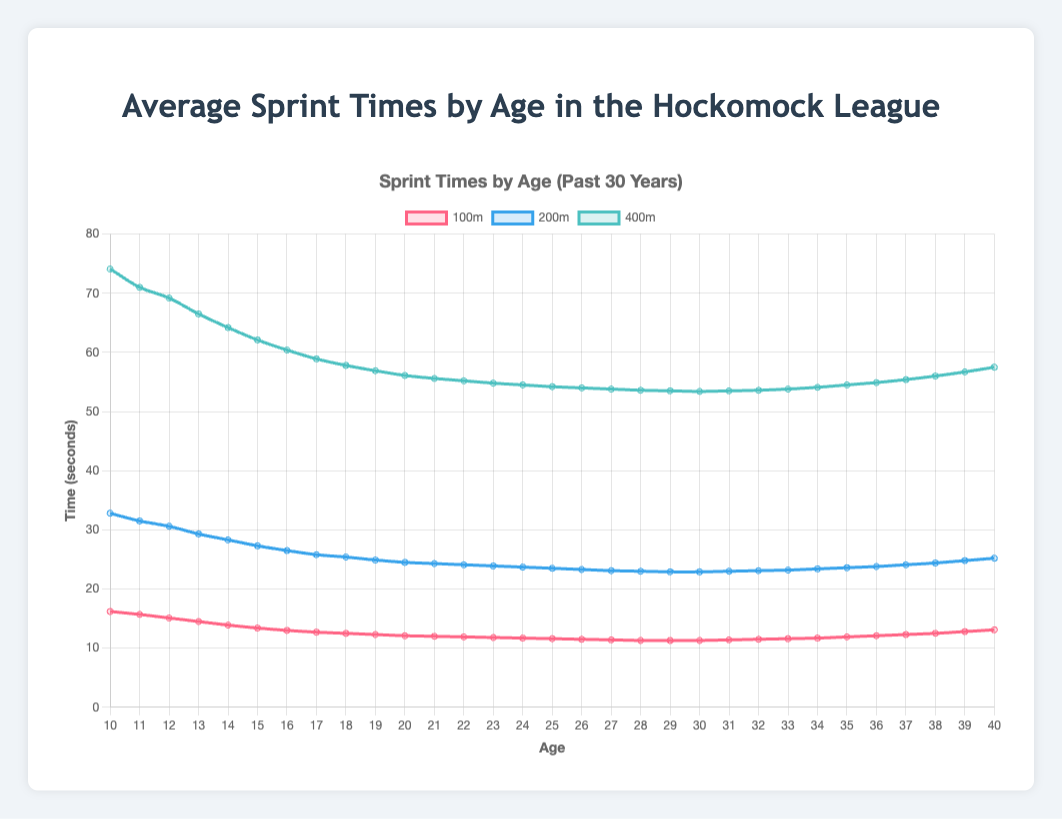What age group has the fastest average 100m time? Look at the 100m trend line and find the lowest point. The lowest point occurs at age 25 with an average time of 11.3 seconds.
Answer: 25 years How do the average 200m and 400m times compare at age 20? For age 20, from the plot, the average time for 200m is around 24.5 seconds, and for 400m it is around 56.1 seconds. The 400m time is more than double the 200m time.
Answer: 24.5s for 200m, 56.1s for 400m At what age does the average 100m sprint time stabilize, showing the smallest changes? The 100m line stabilizes around the age of 28-30, showing minimal fluctuations.
Answer: Around 28-30 years What's the difference in 100m times between ages 10 and 30? The average 100m time for age 10 is 16.2s, and for age 30 it is 11.3s. The difference is 16.2 - 11.3 seconds.
Answer: 4.9 seconds Compare the average 400m time at age 15 and age 35. Which is higher, and by how much? At age 15, the average 400m time is 62.1 seconds. At age 35, it is 54.5 seconds. The time at age 35 is higher by 62.1 - 54.5 seconds.
Answer: Age 15, 7.6 seconds What's the trend in the 200m times from age 10 to age 20? The 200m times decrease steadily from age 10 to age 20, going from 32.8 seconds to 24.5 seconds, reflecting improving performance with age.
Answer: Decreasing trend Between ages 30 and 40, how much does the average 100m time increase? The 100m times change from 11.3 seconds at age 30 to 13.1 seconds at age 40. The increase is 13.1 - 11.3 seconds.
Answer: 1.8 seconds Which event shows the most dramatic decrease in time from age 10 to age 15? Examine the slopes of all three lines (100m, 200m, 400m). The steepest slope indicates the most dramatic decrease. The 400m line shows the biggest drop in time from 74.1 to 62.1 seconds.
Answer: 400m At what age does the average sprint time in the 200m event reach its minimum? The 200m time reaches its lowest point at age 30, showing a value of around 22.9 seconds.
Answer: 30 years By how much does the average 100m time increase from age 25 to age 40? The 100m time at age 25 is 11.3 seconds and at age 40 is 13.1 seconds. The increase is 13.1 - 11.3 seconds.
Answer: 1.8 seconds 